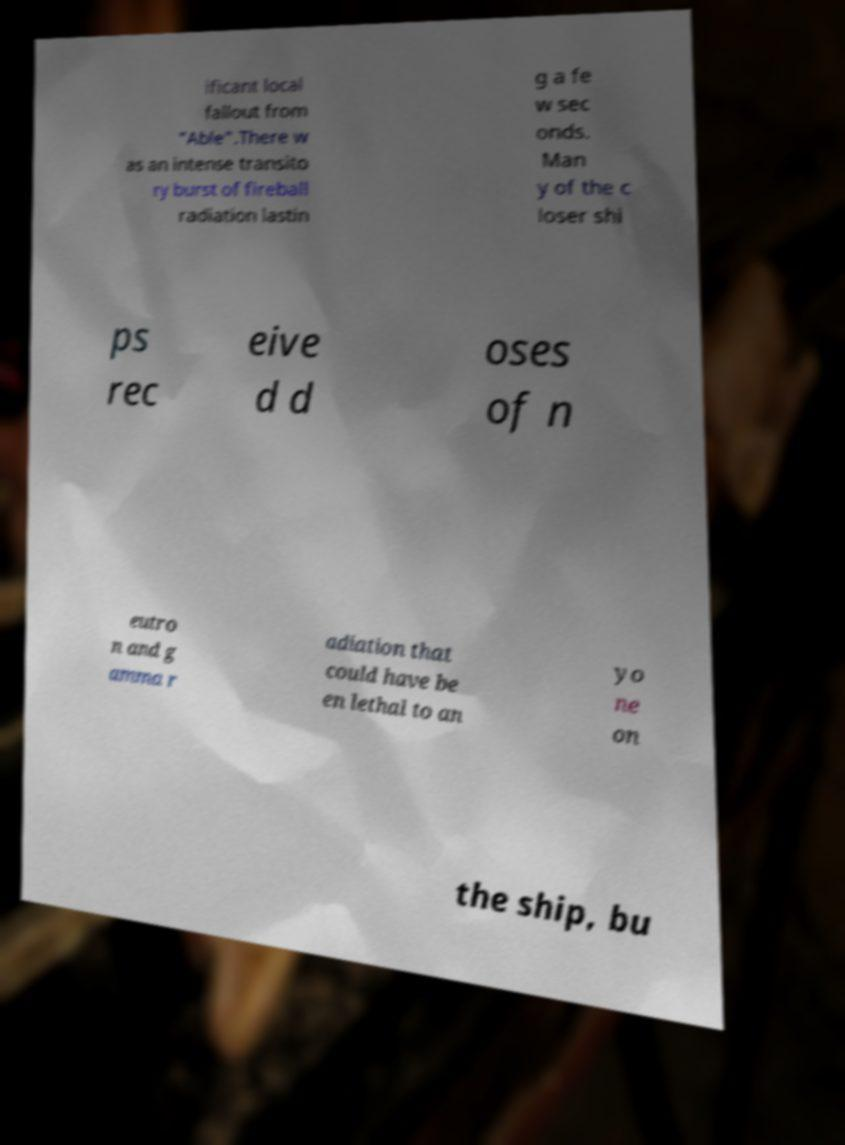Could you assist in decoding the text presented in this image and type it out clearly? ificant local fallout from "Able".There w as an intense transito ry burst of fireball radiation lastin g a fe w sec onds. Man y of the c loser shi ps rec eive d d oses of n eutro n and g amma r adiation that could have be en lethal to an yo ne on the ship, bu 